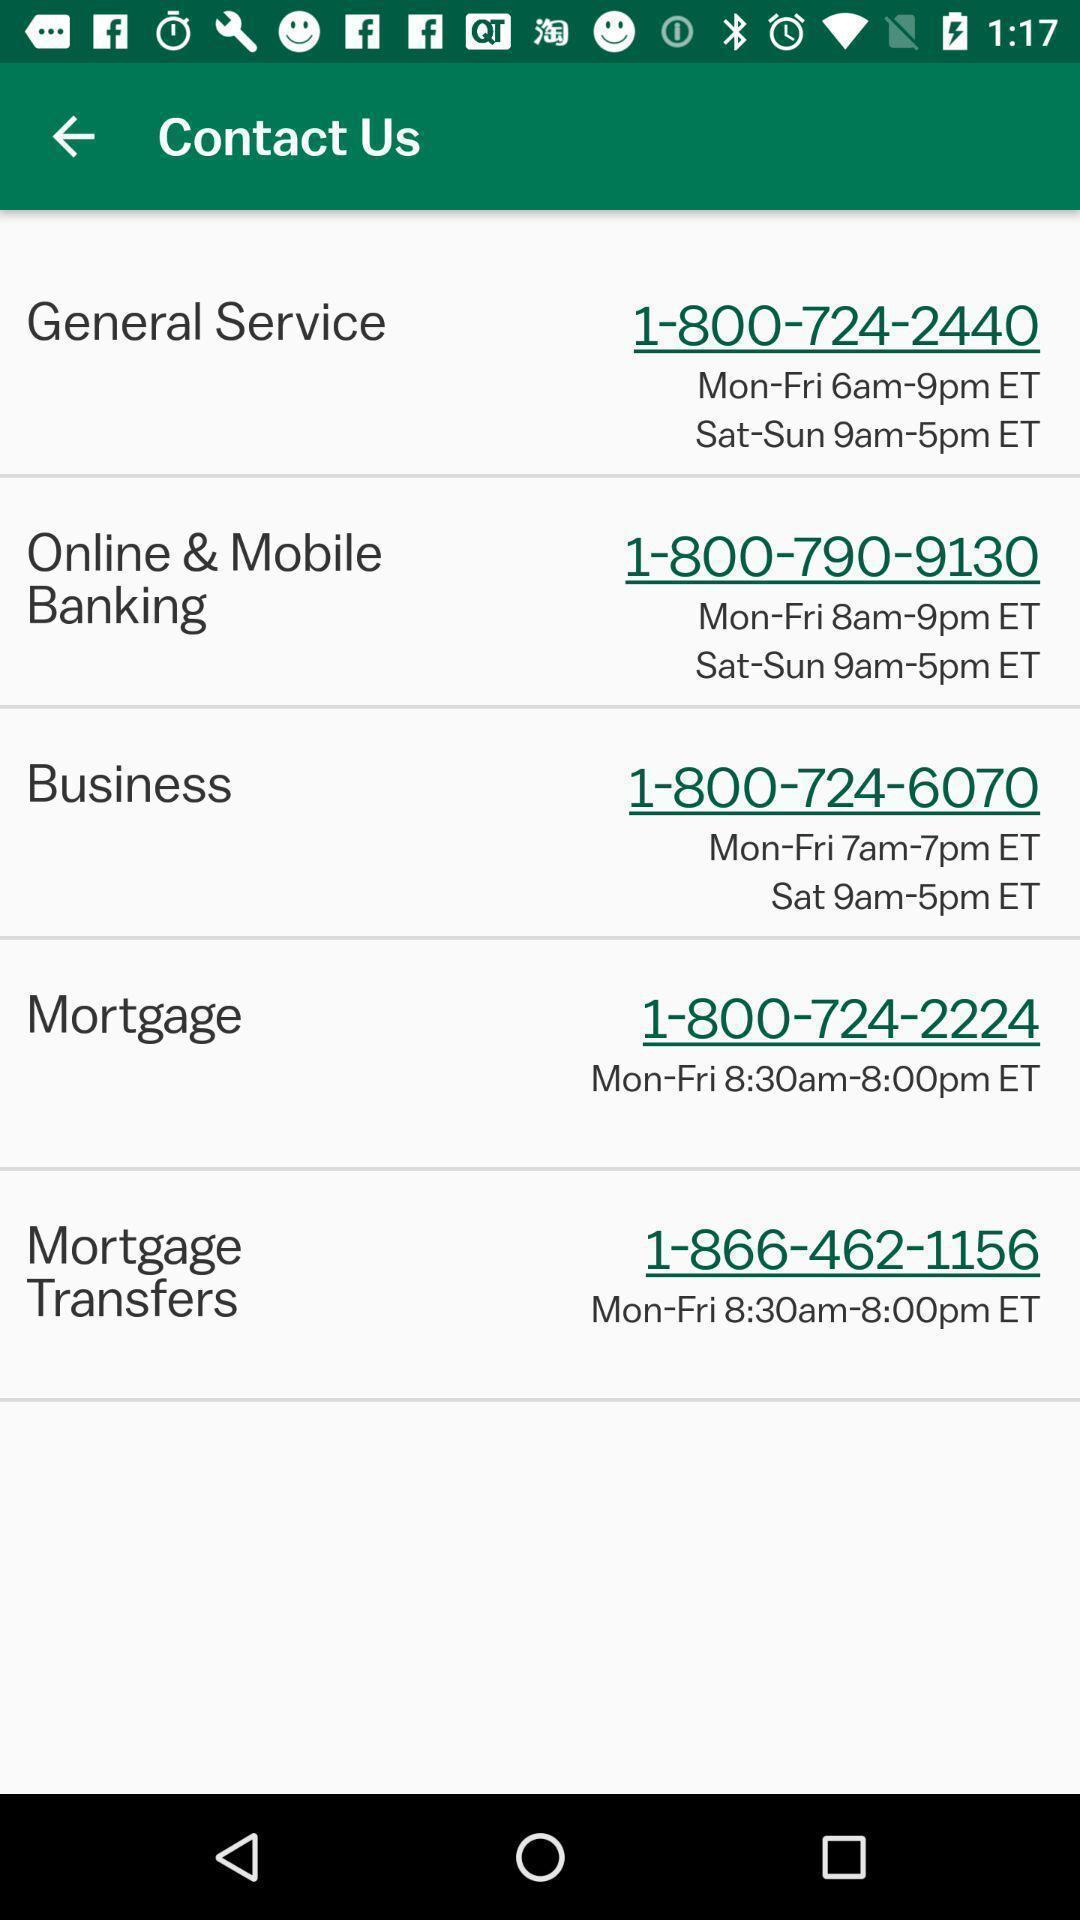Describe this image in words. Screen displaying the contact details. 